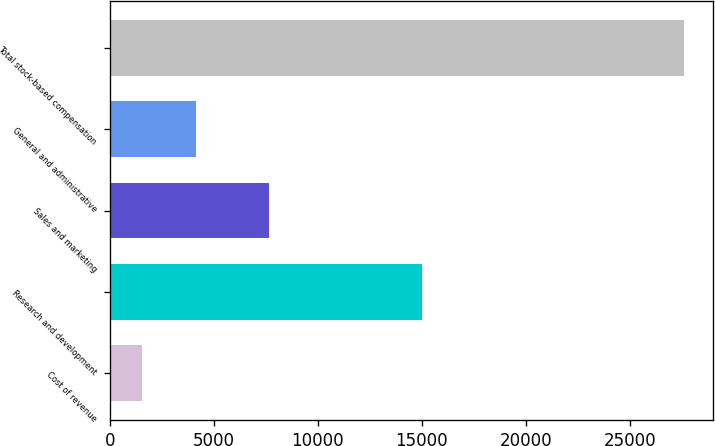Convert chart. <chart><loc_0><loc_0><loc_500><loc_500><bar_chart><fcel>Cost of revenue<fcel>Research and development<fcel>Sales and marketing<fcel>General and administrative<fcel>Total stock-based compensation<nl><fcel>1535<fcel>14986<fcel>7643<fcel>4143.4<fcel>27619<nl></chart> 